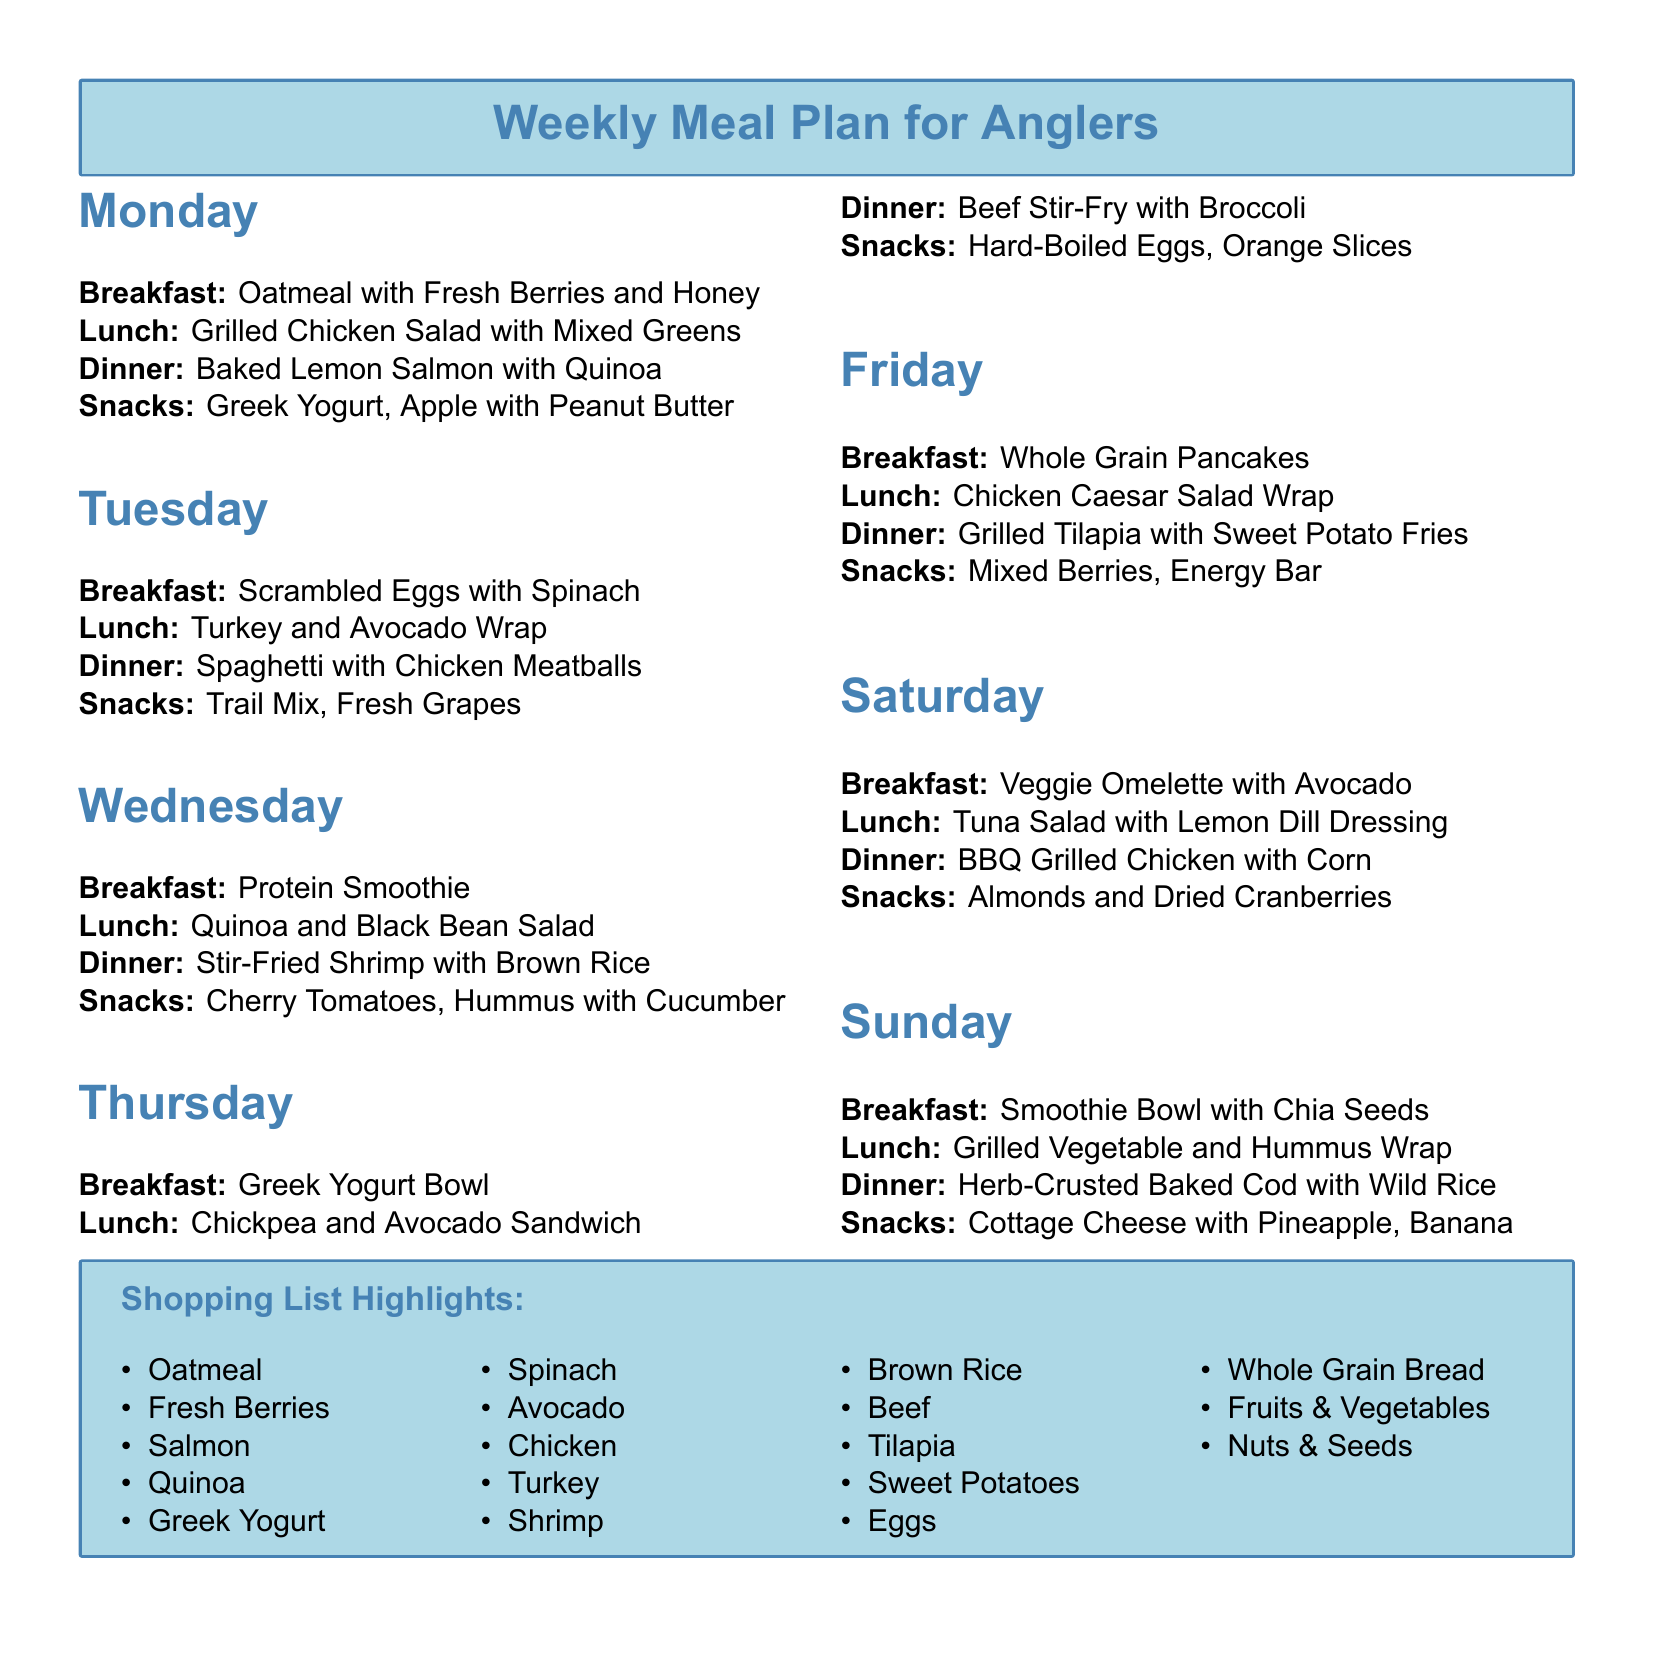What is the breakfast for Monday? The breakfast listed for Monday is Oatmeal with Fresh Berries and Honey.
Answer: Oatmeal with Fresh Berries and Honey What type of fish is included in Wednesday's dinner? The dinner listed for Wednesday features Stir-Fried Shrimp.
Answer: Shrimp How many snacks are listed for Sunday? The document specifies two snacks for Sunday: Cottage Cheese with Pineapple and Banana.
Answer: Two What is the main ingredient in the lunch for Tuesday? The lunch listed for Tuesday is a Turkey and Avocado Wrap, highlighting turkey as the main ingredient.
Answer: Turkey Which day features Grilled Chicken as a dinner option? Grilled Chicken is listed as the dinner option for Saturday.
Answer: Saturday What ingredient is common in both breakfast and lunch on Thursday? Both the breakfast (Greek Yogurt Bowl) and lunch (Chickpea and Avocado Sandwich) contain a form of yogurt.
Answer: Yogurt How many times is Quinoa mentioned in the meal plan? Quinoa is mentioned twice: once for dinner on Monday and once for lunch on Wednesday.
Answer: Twice What type of salad is listed for lunch on Wednesday? The lunch for Wednesday features a Quinoa and Black Bean Salad.
Answer: Quinoa and Black Bean Salad Which day has a breakfast that includes pancakes? The day that features Whole Grain Pancakes for breakfast is Friday.
Answer: Friday 